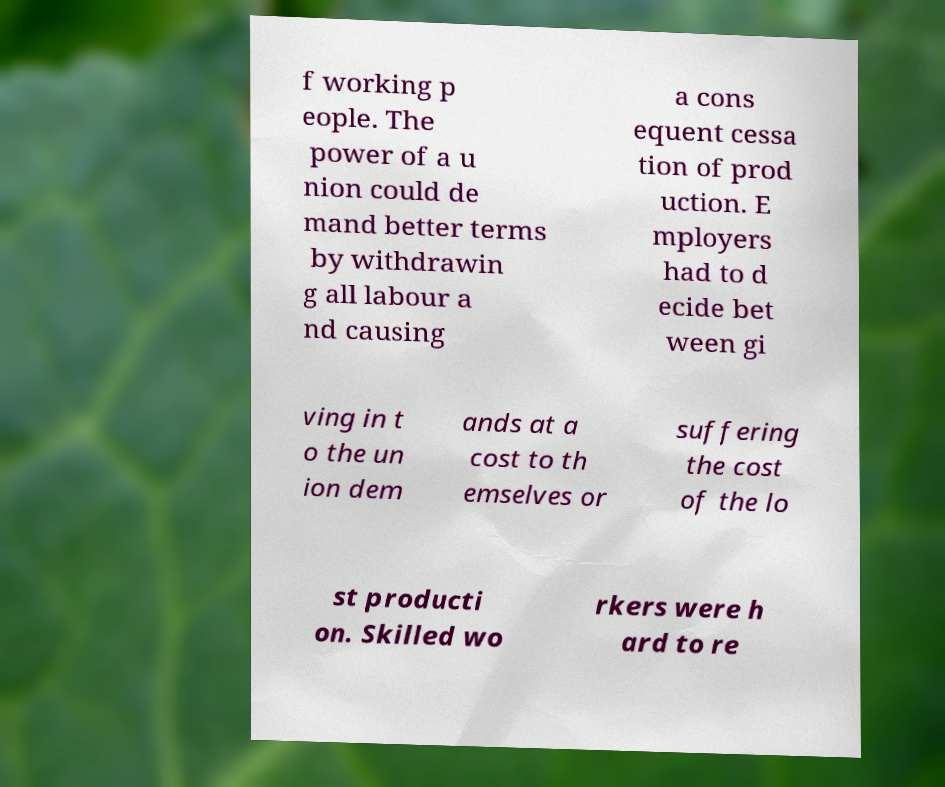Please identify and transcribe the text found in this image. f working p eople. The power of a u nion could de mand better terms by withdrawin g all labour a nd causing a cons equent cessa tion of prod uction. E mployers had to d ecide bet ween gi ving in t o the un ion dem ands at a cost to th emselves or suffering the cost of the lo st producti on. Skilled wo rkers were h ard to re 